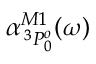<formula> <loc_0><loc_0><loc_500><loc_500>\alpha _ { \, ^ { 3 } P _ { 0 } ^ { o } } ^ { M 1 } ( \omega )</formula> 